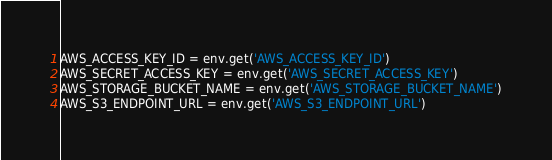Convert code to text. <code><loc_0><loc_0><loc_500><loc_500><_Python_>
AWS_ACCESS_KEY_ID = env.get('AWS_ACCESS_KEY_ID')
AWS_SECRET_ACCESS_KEY = env.get('AWS_SECRET_ACCESS_KEY')
AWS_STORAGE_BUCKET_NAME = env.get('AWS_STORAGE_BUCKET_NAME')
AWS_S3_ENDPOINT_URL = env.get('AWS_S3_ENDPOINT_URL')
</code> 